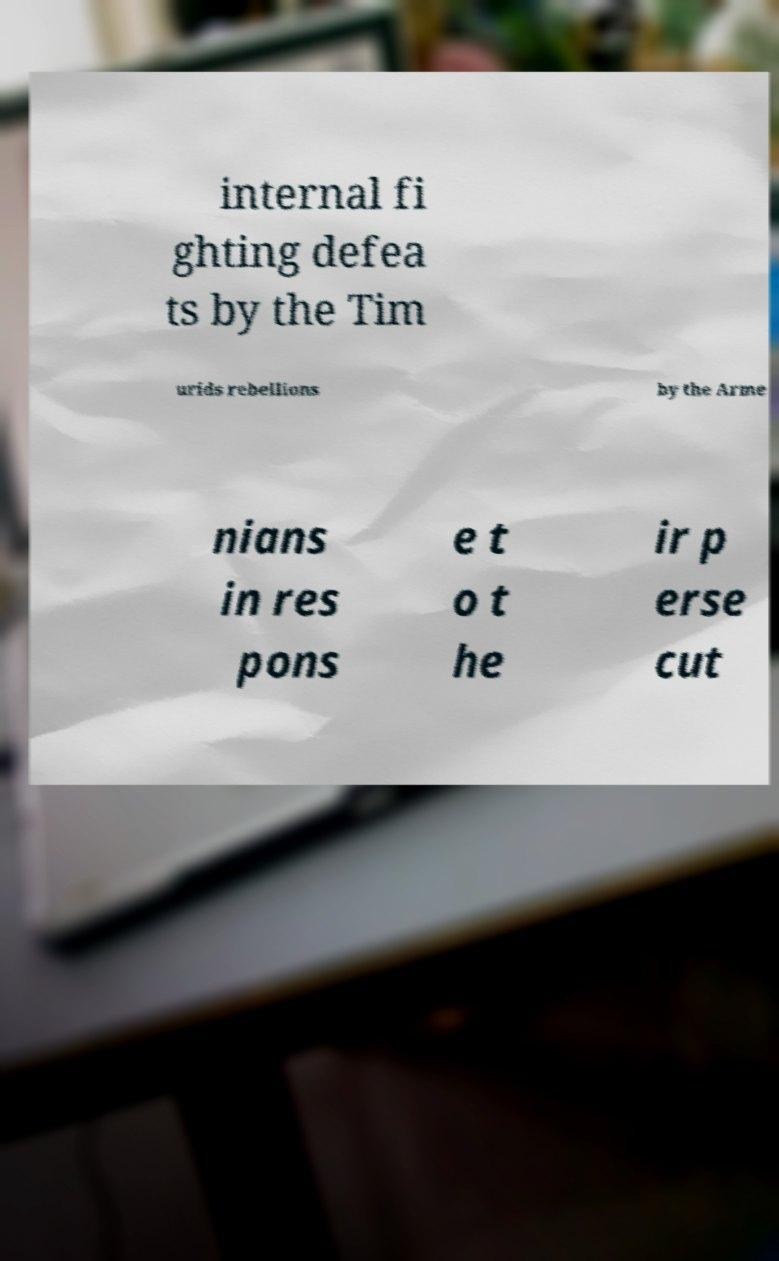For documentation purposes, I need the text within this image transcribed. Could you provide that? internal fi ghting defea ts by the Tim urids rebellions by the Arme nians in res pons e t o t he ir p erse cut 